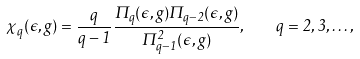<formula> <loc_0><loc_0><loc_500><loc_500>\chi _ { q } ( \epsilon , g ) = \frac { q } { q - 1 } \frac { \Pi _ { q } ( \epsilon , g ) \Pi _ { q - 2 } ( \epsilon , g ) } { \Pi ^ { 2 } _ { q - 1 } ( \epsilon , g ) } , \quad q = 2 , 3 , \dots ,</formula> 